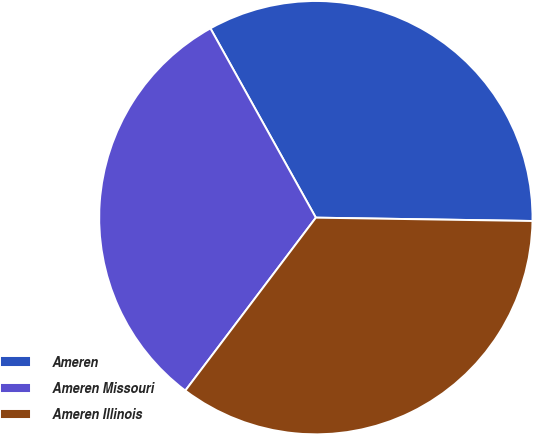Convert chart. <chart><loc_0><loc_0><loc_500><loc_500><pie_chart><fcel>Ameren<fcel>Ameren Missouri<fcel>Ameren Illinois<nl><fcel>33.33%<fcel>31.62%<fcel>35.04%<nl></chart> 